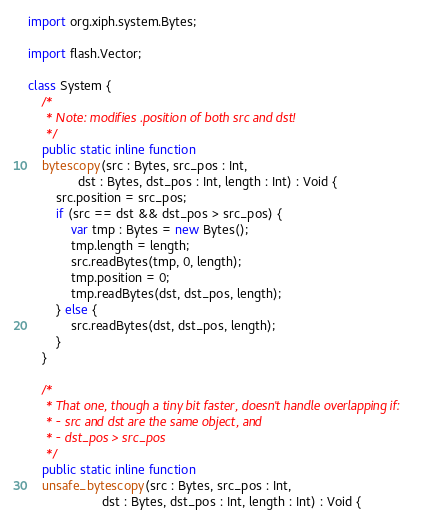Convert code to text. <code><loc_0><loc_0><loc_500><loc_500><_Haxe_>import org.xiph.system.Bytes;

import flash.Vector;

class System {
    /*
     * Note: modifies .position of both src and dst!
     */
    public static inline function
    bytescopy(src : Bytes, src_pos : Int,
              dst : Bytes, dst_pos : Int, length : Int) : Void {
        src.position = src_pos;
        if (src == dst && dst_pos > src_pos) {
            var tmp : Bytes = new Bytes();
            tmp.length = length;
            src.readBytes(tmp, 0, length);
            tmp.position = 0;
            tmp.readBytes(dst, dst_pos, length);
        } else {
            src.readBytes(dst, dst_pos, length);
        }
    }

    /*
     * That one, though a tiny bit faster, doesn't handle overlapping if:
     * - src and dst are the same object, and
     * - dst_pos > src_pos
     */
    public static inline function
    unsafe_bytescopy(src : Bytes, src_pos : Int,
                     dst : Bytes, dst_pos : Int, length : Int) : Void {</code> 